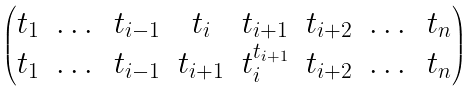Convert formula to latex. <formula><loc_0><loc_0><loc_500><loc_500>\begin{pmatrix} t _ { 1 } & \dots & t _ { i - 1 } & t _ { i } & t _ { i + 1 } & t _ { i + 2 } & \dots & t _ { n } \\ t _ { 1 } & \dots & t _ { i - 1 } & t _ { i + 1 } & t _ { i } ^ { t _ { i + 1 } } & t _ { i + 2 } & \dots & t _ { n } \end{pmatrix}</formula> 